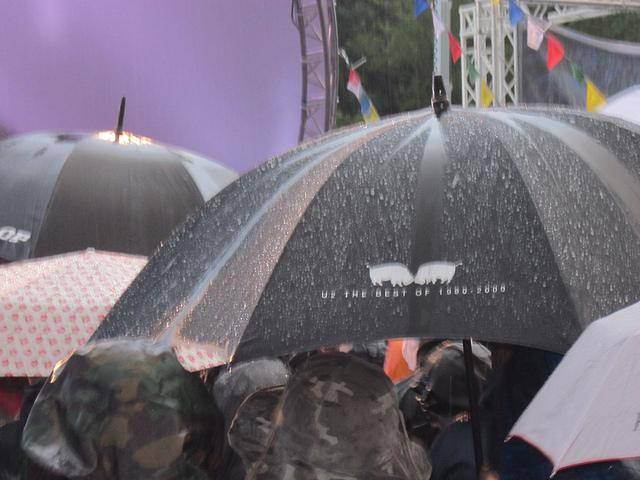What is happening here? raining 